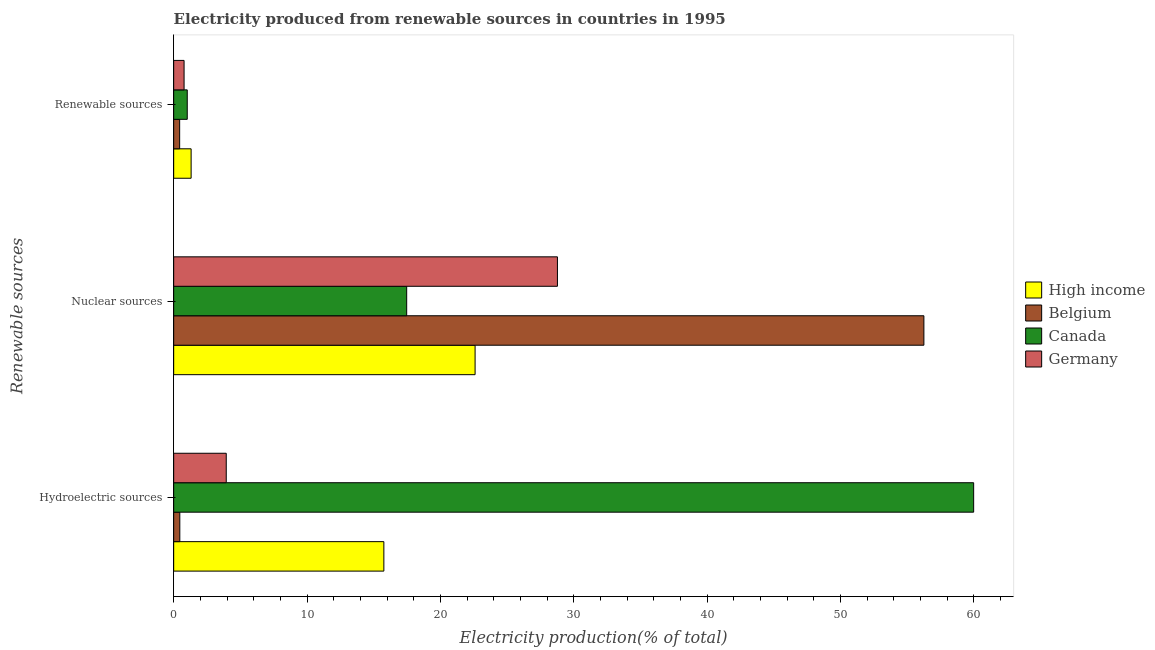Are the number of bars on each tick of the Y-axis equal?
Offer a very short reply. Yes. How many bars are there on the 2nd tick from the top?
Provide a short and direct response. 4. What is the label of the 2nd group of bars from the top?
Ensure brevity in your answer.  Nuclear sources. What is the percentage of electricity produced by hydroelectric sources in Germany?
Provide a succinct answer. 3.94. Across all countries, what is the maximum percentage of electricity produced by renewable sources?
Keep it short and to the point. 1.31. Across all countries, what is the minimum percentage of electricity produced by nuclear sources?
Your answer should be compact. 17.47. What is the total percentage of electricity produced by nuclear sources in the graph?
Your answer should be very brief. 125.1. What is the difference between the percentage of electricity produced by hydroelectric sources in High income and that in Canada?
Make the answer very short. -44.23. What is the difference between the percentage of electricity produced by nuclear sources in Germany and the percentage of electricity produced by renewable sources in Belgium?
Provide a succinct answer. 28.33. What is the average percentage of electricity produced by nuclear sources per country?
Make the answer very short. 31.28. What is the difference between the percentage of electricity produced by nuclear sources and percentage of electricity produced by renewable sources in Canada?
Offer a terse response. 16.45. In how many countries, is the percentage of electricity produced by renewable sources greater than 54 %?
Provide a succinct answer. 0. What is the ratio of the percentage of electricity produced by renewable sources in Canada to that in Germany?
Your answer should be very brief. 1.3. Is the difference between the percentage of electricity produced by renewable sources in Canada and High income greater than the difference between the percentage of electricity produced by hydroelectric sources in Canada and High income?
Offer a terse response. No. What is the difference between the highest and the second highest percentage of electricity produced by renewable sources?
Your answer should be very brief. 0.29. What is the difference between the highest and the lowest percentage of electricity produced by renewable sources?
Provide a short and direct response. 0.86. Is the sum of the percentage of electricity produced by hydroelectric sources in High income and Belgium greater than the maximum percentage of electricity produced by nuclear sources across all countries?
Offer a very short reply. No. What does the 1st bar from the top in Renewable sources represents?
Offer a terse response. Germany. How many bars are there?
Offer a terse response. 12. How many countries are there in the graph?
Keep it short and to the point. 4. What is the difference between two consecutive major ticks on the X-axis?
Provide a succinct answer. 10. Are the values on the major ticks of X-axis written in scientific E-notation?
Your answer should be compact. No. Does the graph contain any zero values?
Keep it short and to the point. No. Does the graph contain grids?
Your answer should be very brief. No. Where does the legend appear in the graph?
Your response must be concise. Center right. How are the legend labels stacked?
Your answer should be compact. Vertical. What is the title of the graph?
Offer a terse response. Electricity produced from renewable sources in countries in 1995. Does "Andorra" appear as one of the legend labels in the graph?
Your answer should be very brief. No. What is the label or title of the X-axis?
Provide a short and direct response. Electricity production(% of total). What is the label or title of the Y-axis?
Ensure brevity in your answer.  Renewable sources. What is the Electricity production(% of total) in High income in Hydroelectric sources?
Offer a very short reply. 15.76. What is the Electricity production(% of total) of Belgium in Hydroelectric sources?
Give a very brief answer. 0.46. What is the Electricity production(% of total) of Canada in Hydroelectric sources?
Provide a short and direct response. 59.99. What is the Electricity production(% of total) in Germany in Hydroelectric sources?
Your response must be concise. 3.94. What is the Electricity production(% of total) of High income in Nuclear sources?
Your answer should be compact. 22.6. What is the Electricity production(% of total) of Belgium in Nuclear sources?
Provide a short and direct response. 56.25. What is the Electricity production(% of total) in Canada in Nuclear sources?
Offer a very short reply. 17.47. What is the Electricity production(% of total) of Germany in Nuclear sources?
Offer a terse response. 28.78. What is the Electricity production(% of total) of High income in Renewable sources?
Your answer should be compact. 1.31. What is the Electricity production(% of total) in Belgium in Renewable sources?
Make the answer very short. 0.45. What is the Electricity production(% of total) in Canada in Renewable sources?
Your answer should be compact. 1.02. What is the Electricity production(% of total) of Germany in Renewable sources?
Offer a very short reply. 0.78. Across all Renewable sources, what is the maximum Electricity production(% of total) in High income?
Make the answer very short. 22.6. Across all Renewable sources, what is the maximum Electricity production(% of total) in Belgium?
Your answer should be very brief. 56.25. Across all Renewable sources, what is the maximum Electricity production(% of total) in Canada?
Ensure brevity in your answer.  59.99. Across all Renewable sources, what is the maximum Electricity production(% of total) in Germany?
Ensure brevity in your answer.  28.78. Across all Renewable sources, what is the minimum Electricity production(% of total) of High income?
Your answer should be compact. 1.31. Across all Renewable sources, what is the minimum Electricity production(% of total) of Belgium?
Provide a short and direct response. 0.45. Across all Renewable sources, what is the minimum Electricity production(% of total) in Canada?
Offer a very short reply. 1.02. Across all Renewable sources, what is the minimum Electricity production(% of total) in Germany?
Give a very brief answer. 0.78. What is the total Electricity production(% of total) in High income in the graph?
Offer a very short reply. 39.67. What is the total Electricity production(% of total) in Belgium in the graph?
Your answer should be compact. 57.16. What is the total Electricity production(% of total) in Canada in the graph?
Your response must be concise. 78.48. What is the total Electricity production(% of total) of Germany in the graph?
Your answer should be very brief. 33.5. What is the difference between the Electricity production(% of total) of High income in Hydroelectric sources and that in Nuclear sources?
Make the answer very short. -6.84. What is the difference between the Electricity production(% of total) of Belgium in Hydroelectric sources and that in Nuclear sources?
Provide a succinct answer. -55.79. What is the difference between the Electricity production(% of total) in Canada in Hydroelectric sources and that in Nuclear sources?
Keep it short and to the point. 42.51. What is the difference between the Electricity production(% of total) of Germany in Hydroelectric sources and that in Nuclear sources?
Provide a succinct answer. -24.83. What is the difference between the Electricity production(% of total) of High income in Hydroelectric sources and that in Renewable sources?
Your answer should be compact. 14.45. What is the difference between the Electricity production(% of total) of Belgium in Hydroelectric sources and that in Renewable sources?
Offer a terse response. 0.01. What is the difference between the Electricity production(% of total) of Canada in Hydroelectric sources and that in Renewable sources?
Provide a short and direct response. 58.97. What is the difference between the Electricity production(% of total) of Germany in Hydroelectric sources and that in Renewable sources?
Provide a short and direct response. 3.16. What is the difference between the Electricity production(% of total) of High income in Nuclear sources and that in Renewable sources?
Offer a very short reply. 21.29. What is the difference between the Electricity production(% of total) in Belgium in Nuclear sources and that in Renewable sources?
Ensure brevity in your answer.  55.81. What is the difference between the Electricity production(% of total) of Canada in Nuclear sources and that in Renewable sources?
Offer a terse response. 16.45. What is the difference between the Electricity production(% of total) in Germany in Nuclear sources and that in Renewable sources?
Ensure brevity in your answer.  28. What is the difference between the Electricity production(% of total) in High income in Hydroelectric sources and the Electricity production(% of total) in Belgium in Nuclear sources?
Provide a succinct answer. -40.49. What is the difference between the Electricity production(% of total) of High income in Hydroelectric sources and the Electricity production(% of total) of Canada in Nuclear sources?
Give a very brief answer. -1.71. What is the difference between the Electricity production(% of total) in High income in Hydroelectric sources and the Electricity production(% of total) in Germany in Nuclear sources?
Your response must be concise. -13.02. What is the difference between the Electricity production(% of total) in Belgium in Hydroelectric sources and the Electricity production(% of total) in Canada in Nuclear sources?
Your response must be concise. -17.01. What is the difference between the Electricity production(% of total) in Belgium in Hydroelectric sources and the Electricity production(% of total) in Germany in Nuclear sources?
Ensure brevity in your answer.  -28.32. What is the difference between the Electricity production(% of total) in Canada in Hydroelectric sources and the Electricity production(% of total) in Germany in Nuclear sources?
Offer a very short reply. 31.21. What is the difference between the Electricity production(% of total) in High income in Hydroelectric sources and the Electricity production(% of total) in Belgium in Renewable sources?
Ensure brevity in your answer.  15.31. What is the difference between the Electricity production(% of total) of High income in Hydroelectric sources and the Electricity production(% of total) of Canada in Renewable sources?
Provide a succinct answer. 14.74. What is the difference between the Electricity production(% of total) of High income in Hydroelectric sources and the Electricity production(% of total) of Germany in Renewable sources?
Give a very brief answer. 14.98. What is the difference between the Electricity production(% of total) of Belgium in Hydroelectric sources and the Electricity production(% of total) of Canada in Renewable sources?
Give a very brief answer. -0.56. What is the difference between the Electricity production(% of total) of Belgium in Hydroelectric sources and the Electricity production(% of total) of Germany in Renewable sources?
Your response must be concise. -0.32. What is the difference between the Electricity production(% of total) of Canada in Hydroelectric sources and the Electricity production(% of total) of Germany in Renewable sources?
Provide a succinct answer. 59.21. What is the difference between the Electricity production(% of total) in High income in Nuclear sources and the Electricity production(% of total) in Belgium in Renewable sources?
Ensure brevity in your answer.  22.15. What is the difference between the Electricity production(% of total) in High income in Nuclear sources and the Electricity production(% of total) in Canada in Renewable sources?
Your answer should be compact. 21.58. What is the difference between the Electricity production(% of total) of High income in Nuclear sources and the Electricity production(% of total) of Germany in Renewable sources?
Provide a short and direct response. 21.82. What is the difference between the Electricity production(% of total) of Belgium in Nuclear sources and the Electricity production(% of total) of Canada in Renewable sources?
Offer a very short reply. 55.24. What is the difference between the Electricity production(% of total) of Belgium in Nuclear sources and the Electricity production(% of total) of Germany in Renewable sources?
Your answer should be compact. 55.47. What is the difference between the Electricity production(% of total) in Canada in Nuclear sources and the Electricity production(% of total) in Germany in Renewable sources?
Your answer should be compact. 16.69. What is the average Electricity production(% of total) of High income per Renewable sources?
Provide a succinct answer. 13.22. What is the average Electricity production(% of total) in Belgium per Renewable sources?
Give a very brief answer. 19.05. What is the average Electricity production(% of total) of Canada per Renewable sources?
Offer a very short reply. 26.16. What is the average Electricity production(% of total) of Germany per Renewable sources?
Your answer should be very brief. 11.17. What is the difference between the Electricity production(% of total) in High income and Electricity production(% of total) in Belgium in Hydroelectric sources?
Provide a succinct answer. 15.3. What is the difference between the Electricity production(% of total) in High income and Electricity production(% of total) in Canada in Hydroelectric sources?
Give a very brief answer. -44.23. What is the difference between the Electricity production(% of total) of High income and Electricity production(% of total) of Germany in Hydroelectric sources?
Give a very brief answer. 11.82. What is the difference between the Electricity production(% of total) of Belgium and Electricity production(% of total) of Canada in Hydroelectric sources?
Offer a very short reply. -59.53. What is the difference between the Electricity production(% of total) in Belgium and Electricity production(% of total) in Germany in Hydroelectric sources?
Provide a short and direct response. -3.48. What is the difference between the Electricity production(% of total) in Canada and Electricity production(% of total) in Germany in Hydroelectric sources?
Give a very brief answer. 56.04. What is the difference between the Electricity production(% of total) of High income and Electricity production(% of total) of Belgium in Nuclear sources?
Provide a short and direct response. -33.65. What is the difference between the Electricity production(% of total) of High income and Electricity production(% of total) of Canada in Nuclear sources?
Keep it short and to the point. 5.13. What is the difference between the Electricity production(% of total) in High income and Electricity production(% of total) in Germany in Nuclear sources?
Offer a very short reply. -6.17. What is the difference between the Electricity production(% of total) in Belgium and Electricity production(% of total) in Canada in Nuclear sources?
Your answer should be compact. 38.78. What is the difference between the Electricity production(% of total) of Belgium and Electricity production(% of total) of Germany in Nuclear sources?
Your answer should be compact. 27.48. What is the difference between the Electricity production(% of total) in Canada and Electricity production(% of total) in Germany in Nuclear sources?
Your answer should be compact. -11.3. What is the difference between the Electricity production(% of total) in High income and Electricity production(% of total) in Belgium in Renewable sources?
Give a very brief answer. 0.86. What is the difference between the Electricity production(% of total) of High income and Electricity production(% of total) of Canada in Renewable sources?
Keep it short and to the point. 0.29. What is the difference between the Electricity production(% of total) of High income and Electricity production(% of total) of Germany in Renewable sources?
Provide a short and direct response. 0.53. What is the difference between the Electricity production(% of total) of Belgium and Electricity production(% of total) of Canada in Renewable sources?
Keep it short and to the point. -0.57. What is the difference between the Electricity production(% of total) of Belgium and Electricity production(% of total) of Germany in Renewable sources?
Make the answer very short. -0.33. What is the difference between the Electricity production(% of total) in Canada and Electricity production(% of total) in Germany in Renewable sources?
Provide a succinct answer. 0.24. What is the ratio of the Electricity production(% of total) of High income in Hydroelectric sources to that in Nuclear sources?
Your answer should be very brief. 0.7. What is the ratio of the Electricity production(% of total) in Belgium in Hydroelectric sources to that in Nuclear sources?
Ensure brevity in your answer.  0.01. What is the ratio of the Electricity production(% of total) in Canada in Hydroelectric sources to that in Nuclear sources?
Give a very brief answer. 3.43. What is the ratio of the Electricity production(% of total) of Germany in Hydroelectric sources to that in Nuclear sources?
Offer a terse response. 0.14. What is the ratio of the Electricity production(% of total) of High income in Hydroelectric sources to that in Renewable sources?
Your answer should be very brief. 12.04. What is the ratio of the Electricity production(% of total) of Belgium in Hydroelectric sources to that in Renewable sources?
Offer a terse response. 1.02. What is the ratio of the Electricity production(% of total) of Canada in Hydroelectric sources to that in Renewable sources?
Offer a very short reply. 58.9. What is the ratio of the Electricity production(% of total) of Germany in Hydroelectric sources to that in Renewable sources?
Your response must be concise. 5.05. What is the ratio of the Electricity production(% of total) in High income in Nuclear sources to that in Renewable sources?
Your answer should be compact. 17.27. What is the ratio of the Electricity production(% of total) in Belgium in Nuclear sources to that in Renewable sources?
Give a very brief answer. 125.32. What is the ratio of the Electricity production(% of total) in Canada in Nuclear sources to that in Renewable sources?
Provide a short and direct response. 17.16. What is the ratio of the Electricity production(% of total) of Germany in Nuclear sources to that in Renewable sources?
Your answer should be very brief. 36.87. What is the difference between the highest and the second highest Electricity production(% of total) in High income?
Make the answer very short. 6.84. What is the difference between the highest and the second highest Electricity production(% of total) of Belgium?
Keep it short and to the point. 55.79. What is the difference between the highest and the second highest Electricity production(% of total) in Canada?
Provide a succinct answer. 42.51. What is the difference between the highest and the second highest Electricity production(% of total) of Germany?
Your answer should be very brief. 24.83. What is the difference between the highest and the lowest Electricity production(% of total) in High income?
Offer a terse response. 21.29. What is the difference between the highest and the lowest Electricity production(% of total) in Belgium?
Keep it short and to the point. 55.81. What is the difference between the highest and the lowest Electricity production(% of total) of Canada?
Make the answer very short. 58.97. What is the difference between the highest and the lowest Electricity production(% of total) of Germany?
Your response must be concise. 28. 